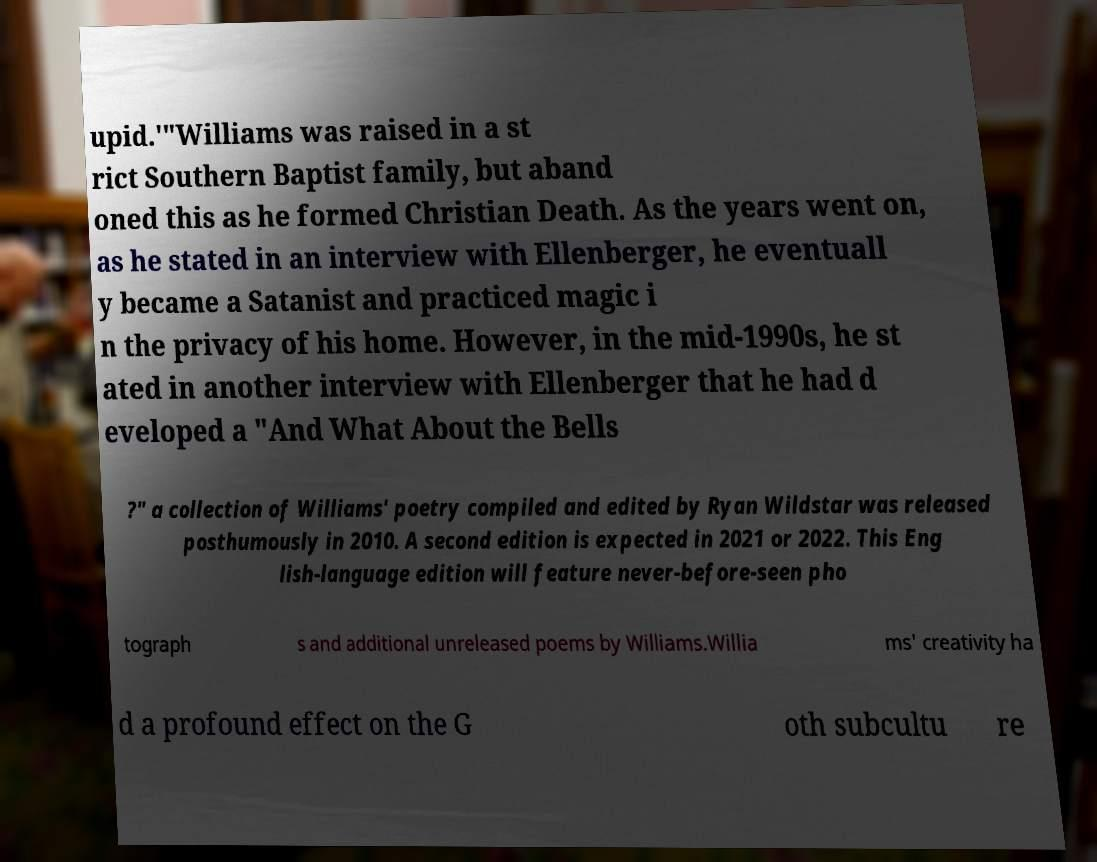Could you assist in decoding the text presented in this image and type it out clearly? upid.'"Williams was raised in a st rict Southern Baptist family, but aband oned this as he formed Christian Death. As the years went on, as he stated in an interview with Ellenberger, he eventuall y became a Satanist and practiced magic i n the privacy of his home. However, in the mid-1990s, he st ated in another interview with Ellenberger that he had d eveloped a "And What About the Bells ?" a collection of Williams' poetry compiled and edited by Ryan Wildstar was released posthumously in 2010. A second edition is expected in 2021 or 2022. This Eng lish-language edition will feature never-before-seen pho tograph s and additional unreleased poems by Williams.Willia ms' creativity ha d a profound effect on the G oth subcultu re 